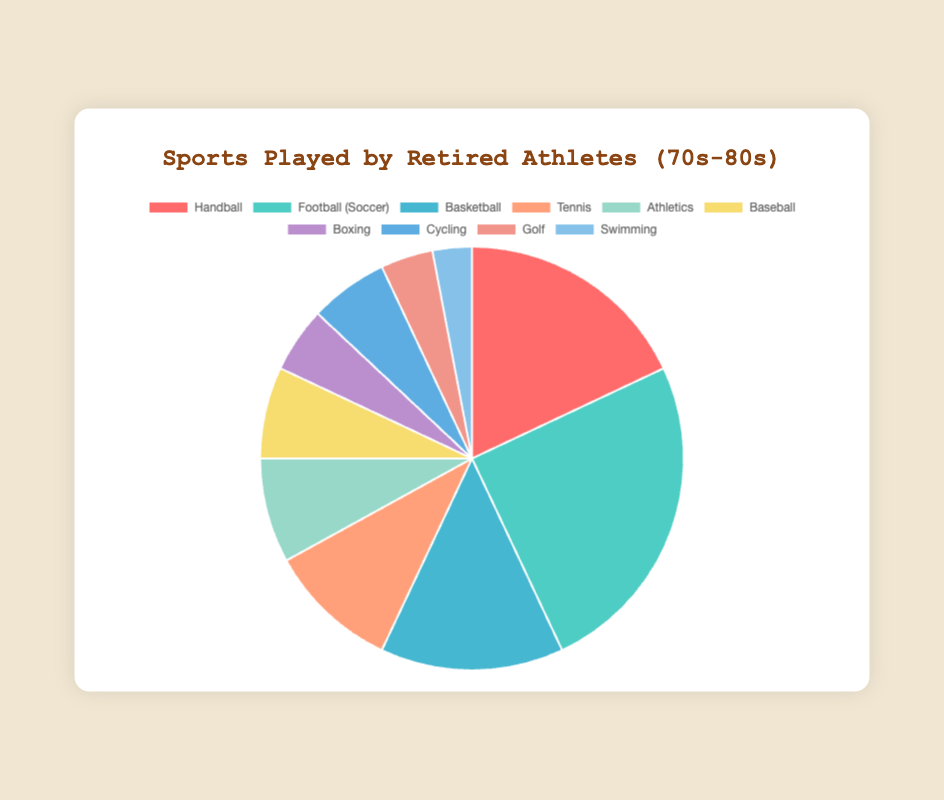What sport has the highest percentage of retired athletes? The sport with the highest percentage can be identified by looking at the segment of the pie chart that occupies the largest area. Here, it's Football (Soccer) at 25%.
Answer: Football (Soccer) How many sports have a percentage greater than 10%? Observe the pie chart and count the number of sports segments where the percentage data is greater than 10%. The sports are Football (Soccer), Handball, and Basketball.
Answer: 3 Which sport has a percentage double that of Golf? Identify the percentage for Golf, which is 4%. Double this value is 8%. Athletics has a percentage of 8%, which matches the requirement.
Answer: Athletics What is the combined percentage of Handball, Tennis, and Basketball? Sum the percentages of Handball (18%), Tennis (10%), and Basketball (14%). The calculation is 18 + 10 + 14 = 42%.
Answer: 42% Which sport has a lower percentage, Swimming or Boxing? Refer to the pie chart and compare the segments for Swimming and Boxing. Swimming shows 3%, while Boxing shows 5%. Swimming has a lower percentage.
Answer: Swimming Is the percentage of athletes who played Baseball higher than those who played Athletics? Compare the percentages: Baseball is 7%, while Athletics is 8%. Baseball's percentage is not higher.
Answer: No Which sport is represented by the lightest color segment in the pie chart? The segment with the lightest color represents Swimming, with a percentage of 3%. To determine this, visually compare the segments' colors shown in the chart.
Answer: Swimming What is the difference in percentage between the sports with the highest and lowest values? Identify the highest percentage (Football (Soccer) at 25%) and the lowest percentage (Swimming at 3%). Calculate the difference: 25 - 3 = 22%.
Answer: 22% How does the percentage of athletes who played Tennis compare to those who played Golf? Compare the Tennis segment (10%) to the Golf segment (4%). Tennis has a higher percentage.
Answer: Tennis What portion of the pie chart is comprised of the combined percentages of Cycling and Boxing? Add the percentages of Cycling (6%) and Boxing (5%). The total is 6 + 5 = 11%.
Answer: 11% 